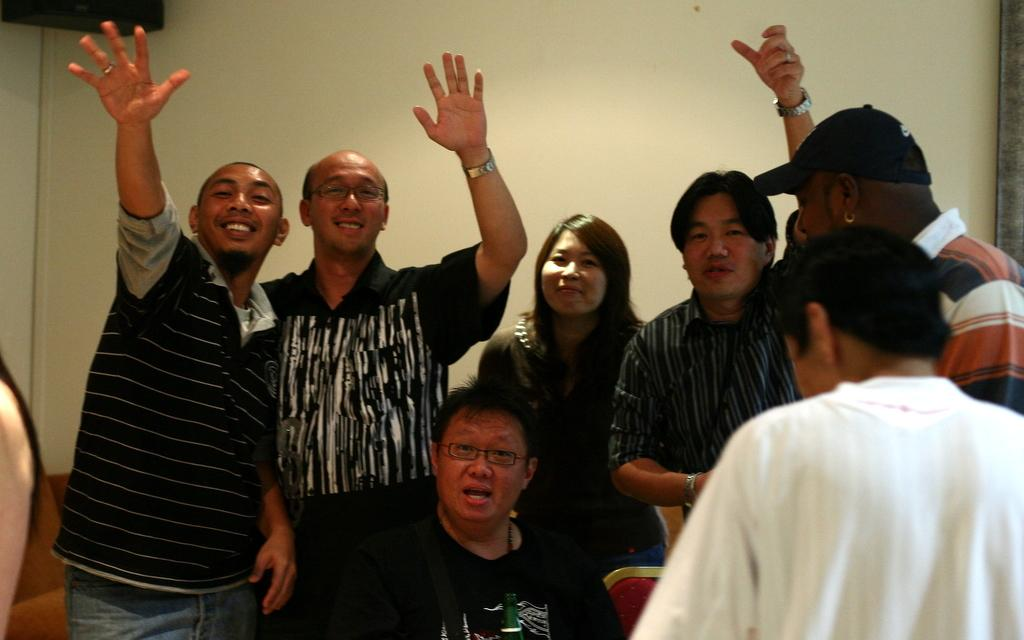How many people are in the image? There is a group of people standing in the image, along with a person sitting. What are the people in the image doing? The people are standing or sitting, but their specific actions are not clear from the provided facts. What can be seen in the background of the image? There is a wall and an object in the background of the image. What color is the sheep in the image? There is no sheep present in the image. What book is the person reading in the image? There is no mention of reading or a book in the image. 